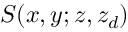Convert formula to latex. <formula><loc_0><loc_0><loc_500><loc_500>S ( x , y ; z , z _ { d } )</formula> 